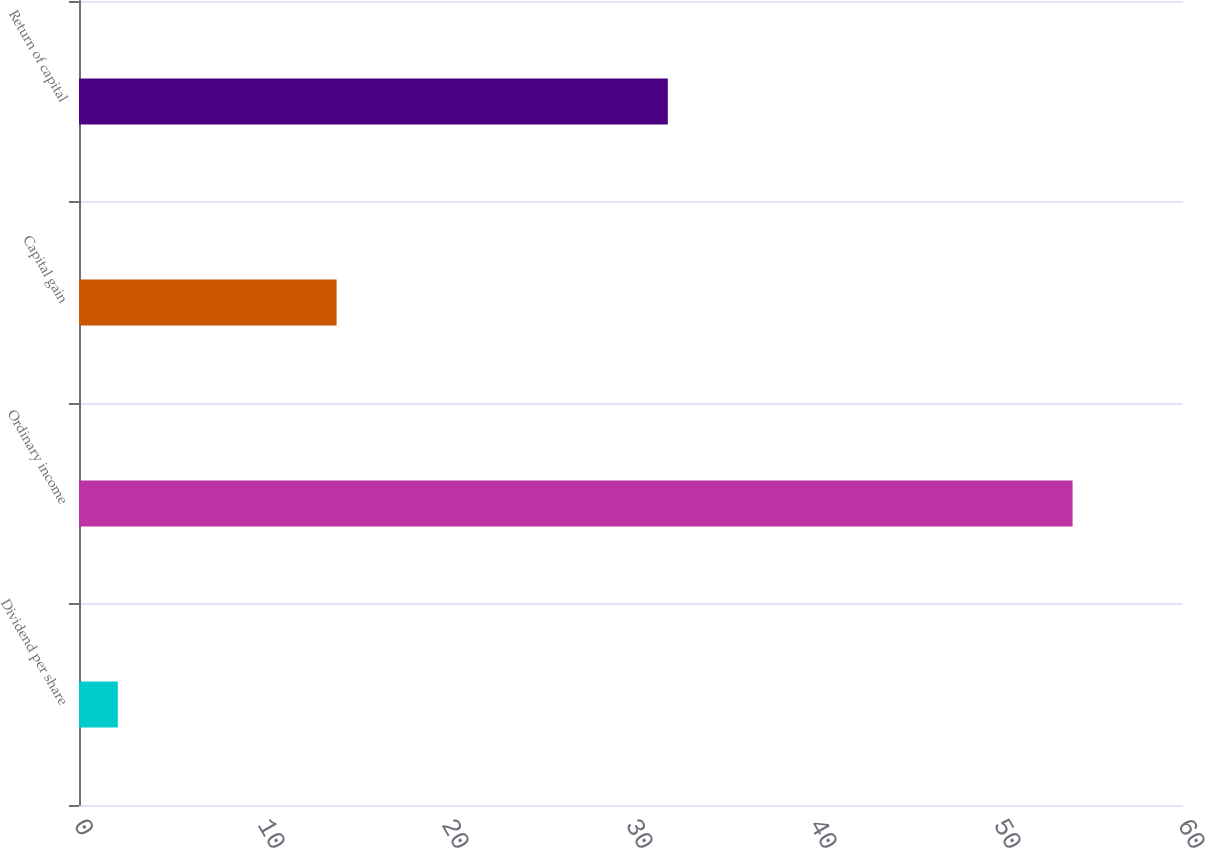<chart> <loc_0><loc_0><loc_500><loc_500><bar_chart><fcel>Dividend per share<fcel>Ordinary income<fcel>Capital gain<fcel>Return of capital<nl><fcel>2.11<fcel>54<fcel>14<fcel>32<nl></chart> 